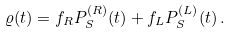<formula> <loc_0><loc_0><loc_500><loc_500>\varrho ( t ) = f _ { R } P _ { S } ^ { ( R ) } ( t ) + f _ { L } P _ { S } ^ { ( L ) } ( t ) \, .</formula> 